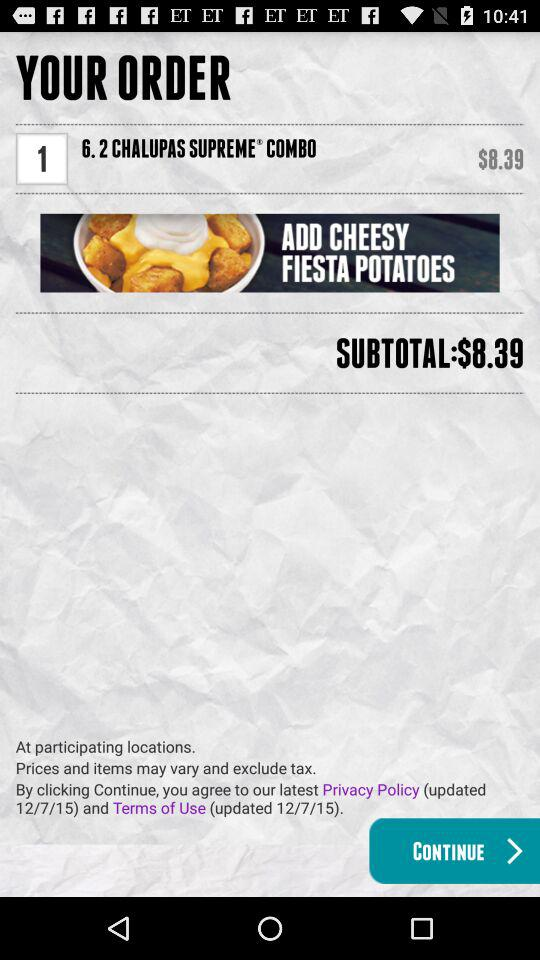What is the total amount of order? The total amount of order is $8.39. 